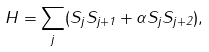<formula> <loc_0><loc_0><loc_500><loc_500>H = \sum _ { j } ( S _ { j } S _ { j + 1 } + \alpha S _ { j } S _ { j + 2 } ) ,</formula> 